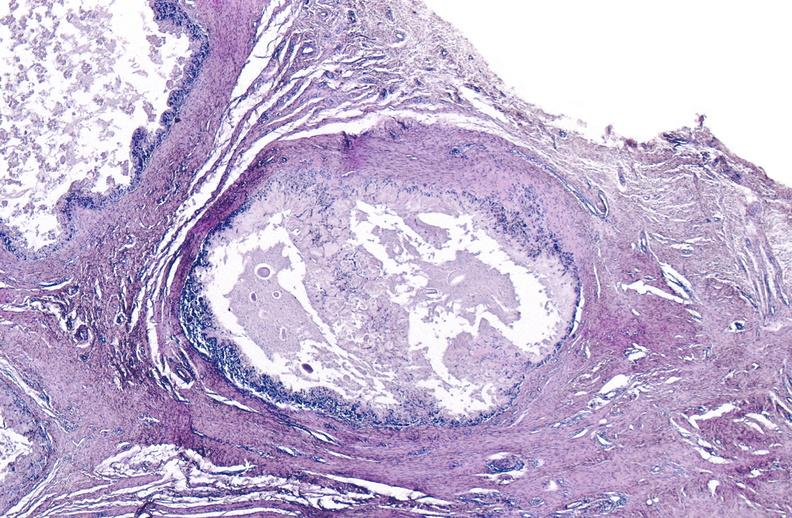does quite good liver show gout?
Answer the question using a single word or phrase. No 